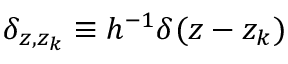<formula> <loc_0><loc_0><loc_500><loc_500>\delta _ { z , z _ { k } } \equiv h ^ { - 1 } \delta ( z - z _ { k } )</formula> 